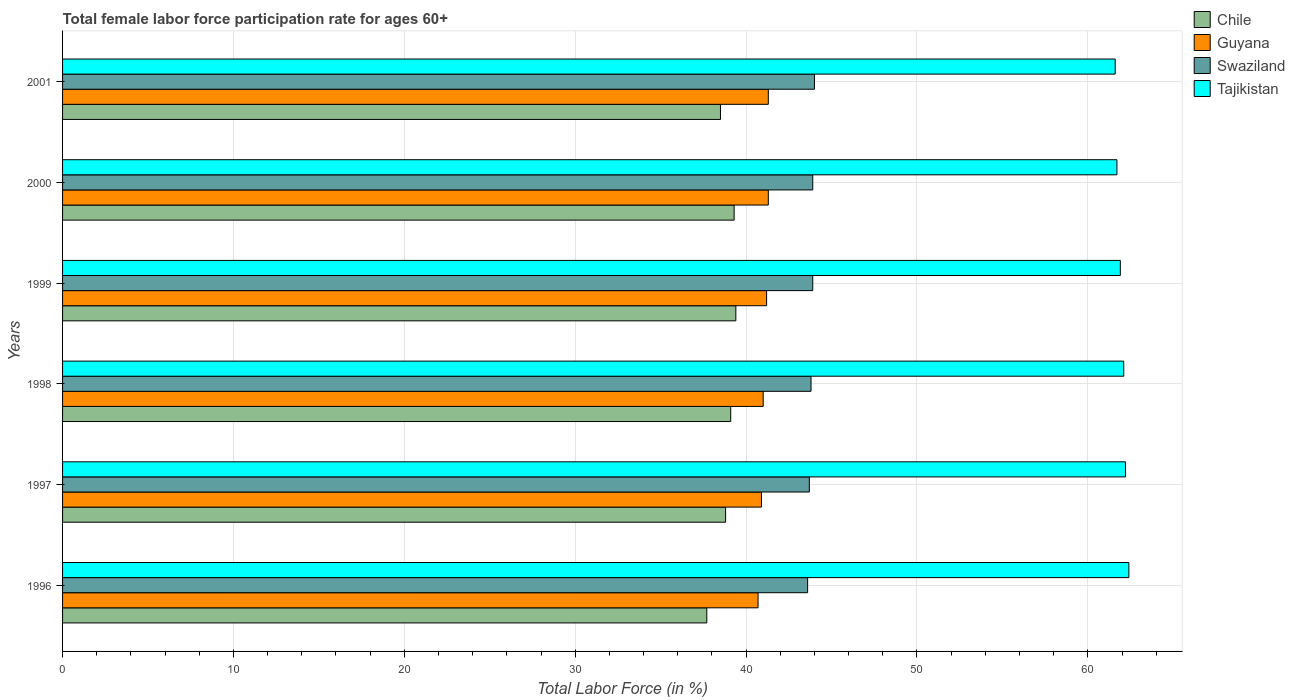How many different coloured bars are there?
Offer a terse response. 4. How many bars are there on the 6th tick from the bottom?
Your answer should be compact. 4. In how many cases, is the number of bars for a given year not equal to the number of legend labels?
Provide a short and direct response. 0. What is the female labor force participation rate in Guyana in 2001?
Offer a very short reply. 41.3. Across all years, what is the maximum female labor force participation rate in Tajikistan?
Your response must be concise. 62.4. Across all years, what is the minimum female labor force participation rate in Chile?
Your answer should be very brief. 37.7. In which year was the female labor force participation rate in Tajikistan maximum?
Your answer should be compact. 1996. What is the total female labor force participation rate in Tajikistan in the graph?
Provide a succinct answer. 371.9. What is the difference between the female labor force participation rate in Tajikistan in 1997 and that in 2000?
Offer a terse response. 0.5. What is the difference between the female labor force participation rate in Chile in 1996 and the female labor force participation rate in Swaziland in 1998?
Offer a very short reply. -6.1. What is the average female labor force participation rate in Tajikistan per year?
Your answer should be very brief. 61.98. In the year 2000, what is the difference between the female labor force participation rate in Chile and female labor force participation rate in Guyana?
Give a very brief answer. -2. What is the ratio of the female labor force participation rate in Tajikistan in 1996 to that in 2001?
Your answer should be compact. 1.01. Is the difference between the female labor force participation rate in Chile in 1996 and 1997 greater than the difference between the female labor force participation rate in Guyana in 1996 and 1997?
Make the answer very short. No. What is the difference between the highest and the second highest female labor force participation rate in Chile?
Provide a succinct answer. 0.1. What is the difference between the highest and the lowest female labor force participation rate in Swaziland?
Your answer should be very brief. 0.4. In how many years, is the female labor force participation rate in Chile greater than the average female labor force participation rate in Chile taken over all years?
Provide a succinct answer. 3. Is the sum of the female labor force participation rate in Guyana in 1996 and 1999 greater than the maximum female labor force participation rate in Chile across all years?
Provide a short and direct response. Yes. What does the 3rd bar from the bottom in 1999 represents?
Offer a terse response. Swaziland. Is it the case that in every year, the sum of the female labor force participation rate in Chile and female labor force participation rate in Swaziland is greater than the female labor force participation rate in Guyana?
Offer a very short reply. Yes. How many years are there in the graph?
Offer a very short reply. 6. Does the graph contain any zero values?
Make the answer very short. No. Where does the legend appear in the graph?
Offer a terse response. Top right. How are the legend labels stacked?
Keep it short and to the point. Vertical. What is the title of the graph?
Offer a terse response. Total female labor force participation rate for ages 60+. Does "Seychelles" appear as one of the legend labels in the graph?
Ensure brevity in your answer.  No. What is the label or title of the X-axis?
Your response must be concise. Total Labor Force (in %). What is the Total Labor Force (in %) in Chile in 1996?
Keep it short and to the point. 37.7. What is the Total Labor Force (in %) in Guyana in 1996?
Make the answer very short. 40.7. What is the Total Labor Force (in %) in Swaziland in 1996?
Offer a very short reply. 43.6. What is the Total Labor Force (in %) in Tajikistan in 1996?
Ensure brevity in your answer.  62.4. What is the Total Labor Force (in %) in Chile in 1997?
Offer a terse response. 38.8. What is the Total Labor Force (in %) in Guyana in 1997?
Provide a succinct answer. 40.9. What is the Total Labor Force (in %) in Swaziland in 1997?
Your answer should be compact. 43.7. What is the Total Labor Force (in %) in Tajikistan in 1997?
Ensure brevity in your answer.  62.2. What is the Total Labor Force (in %) of Chile in 1998?
Provide a short and direct response. 39.1. What is the Total Labor Force (in %) of Guyana in 1998?
Keep it short and to the point. 41. What is the Total Labor Force (in %) of Swaziland in 1998?
Provide a short and direct response. 43.8. What is the Total Labor Force (in %) in Tajikistan in 1998?
Your answer should be very brief. 62.1. What is the Total Labor Force (in %) of Chile in 1999?
Offer a terse response. 39.4. What is the Total Labor Force (in %) of Guyana in 1999?
Offer a very short reply. 41.2. What is the Total Labor Force (in %) in Swaziland in 1999?
Keep it short and to the point. 43.9. What is the Total Labor Force (in %) of Tajikistan in 1999?
Ensure brevity in your answer.  61.9. What is the Total Labor Force (in %) of Chile in 2000?
Provide a short and direct response. 39.3. What is the Total Labor Force (in %) of Guyana in 2000?
Give a very brief answer. 41.3. What is the Total Labor Force (in %) of Swaziland in 2000?
Provide a short and direct response. 43.9. What is the Total Labor Force (in %) in Tajikistan in 2000?
Ensure brevity in your answer.  61.7. What is the Total Labor Force (in %) in Chile in 2001?
Provide a succinct answer. 38.5. What is the Total Labor Force (in %) in Guyana in 2001?
Keep it short and to the point. 41.3. What is the Total Labor Force (in %) in Tajikistan in 2001?
Your answer should be very brief. 61.6. Across all years, what is the maximum Total Labor Force (in %) in Chile?
Your answer should be compact. 39.4. Across all years, what is the maximum Total Labor Force (in %) of Guyana?
Make the answer very short. 41.3. Across all years, what is the maximum Total Labor Force (in %) of Tajikistan?
Provide a short and direct response. 62.4. Across all years, what is the minimum Total Labor Force (in %) of Chile?
Provide a succinct answer. 37.7. Across all years, what is the minimum Total Labor Force (in %) of Guyana?
Ensure brevity in your answer.  40.7. Across all years, what is the minimum Total Labor Force (in %) of Swaziland?
Your answer should be very brief. 43.6. Across all years, what is the minimum Total Labor Force (in %) of Tajikistan?
Your answer should be compact. 61.6. What is the total Total Labor Force (in %) in Chile in the graph?
Your response must be concise. 232.8. What is the total Total Labor Force (in %) of Guyana in the graph?
Your answer should be very brief. 246.4. What is the total Total Labor Force (in %) in Swaziland in the graph?
Ensure brevity in your answer.  262.9. What is the total Total Labor Force (in %) in Tajikistan in the graph?
Ensure brevity in your answer.  371.9. What is the difference between the Total Labor Force (in %) in Chile in 1996 and that in 1997?
Your answer should be very brief. -1.1. What is the difference between the Total Labor Force (in %) of Guyana in 1996 and that in 1997?
Offer a terse response. -0.2. What is the difference between the Total Labor Force (in %) in Swaziland in 1996 and that in 1997?
Make the answer very short. -0.1. What is the difference between the Total Labor Force (in %) in Guyana in 1996 and that in 1999?
Your response must be concise. -0.5. What is the difference between the Total Labor Force (in %) of Swaziland in 1996 and that in 1999?
Keep it short and to the point. -0.3. What is the difference between the Total Labor Force (in %) of Chile in 1996 and that in 2000?
Keep it short and to the point. -1.6. What is the difference between the Total Labor Force (in %) in Swaziland in 1996 and that in 2000?
Your answer should be very brief. -0.3. What is the difference between the Total Labor Force (in %) in Tajikistan in 1996 and that in 2000?
Make the answer very short. 0.7. What is the difference between the Total Labor Force (in %) in Chile in 1996 and that in 2001?
Your answer should be very brief. -0.8. What is the difference between the Total Labor Force (in %) of Guyana in 1996 and that in 2001?
Ensure brevity in your answer.  -0.6. What is the difference between the Total Labor Force (in %) of Chile in 1997 and that in 1998?
Your answer should be very brief. -0.3. What is the difference between the Total Labor Force (in %) of Chile in 1997 and that in 1999?
Give a very brief answer. -0.6. What is the difference between the Total Labor Force (in %) in Swaziland in 1997 and that in 1999?
Your response must be concise. -0.2. What is the difference between the Total Labor Force (in %) in Tajikistan in 1997 and that in 1999?
Your response must be concise. 0.3. What is the difference between the Total Labor Force (in %) in Chile in 1997 and that in 2000?
Your answer should be very brief. -0.5. What is the difference between the Total Labor Force (in %) in Guyana in 1997 and that in 2000?
Your answer should be very brief. -0.4. What is the difference between the Total Labor Force (in %) of Guyana in 1998 and that in 1999?
Provide a succinct answer. -0.2. What is the difference between the Total Labor Force (in %) of Swaziland in 1998 and that in 1999?
Your response must be concise. -0.1. What is the difference between the Total Labor Force (in %) in Guyana in 1998 and that in 2000?
Give a very brief answer. -0.3. What is the difference between the Total Labor Force (in %) of Tajikistan in 1998 and that in 2000?
Make the answer very short. 0.4. What is the difference between the Total Labor Force (in %) of Swaziland in 1998 and that in 2001?
Offer a terse response. -0.2. What is the difference between the Total Labor Force (in %) in Chile in 1999 and that in 2000?
Your response must be concise. 0.1. What is the difference between the Total Labor Force (in %) in Guyana in 1999 and that in 2000?
Provide a succinct answer. -0.1. What is the difference between the Total Labor Force (in %) in Swaziland in 1999 and that in 2000?
Your answer should be compact. 0. What is the difference between the Total Labor Force (in %) of Chile in 1999 and that in 2001?
Provide a short and direct response. 0.9. What is the difference between the Total Labor Force (in %) of Guyana in 1999 and that in 2001?
Your response must be concise. -0.1. What is the difference between the Total Labor Force (in %) in Tajikistan in 1999 and that in 2001?
Your response must be concise. 0.3. What is the difference between the Total Labor Force (in %) in Chile in 2000 and that in 2001?
Offer a very short reply. 0.8. What is the difference between the Total Labor Force (in %) in Swaziland in 2000 and that in 2001?
Ensure brevity in your answer.  -0.1. What is the difference between the Total Labor Force (in %) in Tajikistan in 2000 and that in 2001?
Make the answer very short. 0.1. What is the difference between the Total Labor Force (in %) of Chile in 1996 and the Total Labor Force (in %) of Guyana in 1997?
Provide a short and direct response. -3.2. What is the difference between the Total Labor Force (in %) of Chile in 1996 and the Total Labor Force (in %) of Tajikistan in 1997?
Give a very brief answer. -24.5. What is the difference between the Total Labor Force (in %) of Guyana in 1996 and the Total Labor Force (in %) of Tajikistan in 1997?
Your answer should be compact. -21.5. What is the difference between the Total Labor Force (in %) in Swaziland in 1996 and the Total Labor Force (in %) in Tajikistan in 1997?
Your response must be concise. -18.6. What is the difference between the Total Labor Force (in %) of Chile in 1996 and the Total Labor Force (in %) of Guyana in 1998?
Ensure brevity in your answer.  -3.3. What is the difference between the Total Labor Force (in %) in Chile in 1996 and the Total Labor Force (in %) in Swaziland in 1998?
Your answer should be very brief. -6.1. What is the difference between the Total Labor Force (in %) in Chile in 1996 and the Total Labor Force (in %) in Tajikistan in 1998?
Provide a short and direct response. -24.4. What is the difference between the Total Labor Force (in %) in Guyana in 1996 and the Total Labor Force (in %) in Swaziland in 1998?
Your response must be concise. -3.1. What is the difference between the Total Labor Force (in %) of Guyana in 1996 and the Total Labor Force (in %) of Tajikistan in 1998?
Your answer should be compact. -21.4. What is the difference between the Total Labor Force (in %) in Swaziland in 1996 and the Total Labor Force (in %) in Tajikistan in 1998?
Provide a succinct answer. -18.5. What is the difference between the Total Labor Force (in %) in Chile in 1996 and the Total Labor Force (in %) in Guyana in 1999?
Ensure brevity in your answer.  -3.5. What is the difference between the Total Labor Force (in %) of Chile in 1996 and the Total Labor Force (in %) of Swaziland in 1999?
Your answer should be very brief. -6.2. What is the difference between the Total Labor Force (in %) in Chile in 1996 and the Total Labor Force (in %) in Tajikistan in 1999?
Your answer should be compact. -24.2. What is the difference between the Total Labor Force (in %) of Guyana in 1996 and the Total Labor Force (in %) of Tajikistan in 1999?
Ensure brevity in your answer.  -21.2. What is the difference between the Total Labor Force (in %) of Swaziland in 1996 and the Total Labor Force (in %) of Tajikistan in 1999?
Offer a terse response. -18.3. What is the difference between the Total Labor Force (in %) of Chile in 1996 and the Total Labor Force (in %) of Tajikistan in 2000?
Give a very brief answer. -24. What is the difference between the Total Labor Force (in %) in Guyana in 1996 and the Total Labor Force (in %) in Swaziland in 2000?
Provide a short and direct response. -3.2. What is the difference between the Total Labor Force (in %) in Guyana in 1996 and the Total Labor Force (in %) in Tajikistan in 2000?
Make the answer very short. -21. What is the difference between the Total Labor Force (in %) of Swaziland in 1996 and the Total Labor Force (in %) of Tajikistan in 2000?
Provide a short and direct response. -18.1. What is the difference between the Total Labor Force (in %) in Chile in 1996 and the Total Labor Force (in %) in Swaziland in 2001?
Provide a short and direct response. -6.3. What is the difference between the Total Labor Force (in %) of Chile in 1996 and the Total Labor Force (in %) of Tajikistan in 2001?
Offer a terse response. -23.9. What is the difference between the Total Labor Force (in %) of Guyana in 1996 and the Total Labor Force (in %) of Swaziland in 2001?
Your answer should be very brief. -3.3. What is the difference between the Total Labor Force (in %) in Guyana in 1996 and the Total Labor Force (in %) in Tajikistan in 2001?
Your response must be concise. -20.9. What is the difference between the Total Labor Force (in %) in Swaziland in 1996 and the Total Labor Force (in %) in Tajikistan in 2001?
Your answer should be very brief. -18. What is the difference between the Total Labor Force (in %) of Chile in 1997 and the Total Labor Force (in %) of Tajikistan in 1998?
Make the answer very short. -23.3. What is the difference between the Total Labor Force (in %) in Guyana in 1997 and the Total Labor Force (in %) in Tajikistan in 1998?
Your response must be concise. -21.2. What is the difference between the Total Labor Force (in %) of Swaziland in 1997 and the Total Labor Force (in %) of Tajikistan in 1998?
Offer a terse response. -18.4. What is the difference between the Total Labor Force (in %) of Chile in 1997 and the Total Labor Force (in %) of Tajikistan in 1999?
Your answer should be very brief. -23.1. What is the difference between the Total Labor Force (in %) of Guyana in 1997 and the Total Labor Force (in %) of Swaziland in 1999?
Your answer should be compact. -3. What is the difference between the Total Labor Force (in %) of Guyana in 1997 and the Total Labor Force (in %) of Tajikistan in 1999?
Your response must be concise. -21. What is the difference between the Total Labor Force (in %) of Swaziland in 1997 and the Total Labor Force (in %) of Tajikistan in 1999?
Offer a very short reply. -18.2. What is the difference between the Total Labor Force (in %) of Chile in 1997 and the Total Labor Force (in %) of Tajikistan in 2000?
Make the answer very short. -22.9. What is the difference between the Total Labor Force (in %) in Guyana in 1997 and the Total Labor Force (in %) in Tajikistan in 2000?
Offer a very short reply. -20.8. What is the difference between the Total Labor Force (in %) of Swaziland in 1997 and the Total Labor Force (in %) of Tajikistan in 2000?
Ensure brevity in your answer.  -18. What is the difference between the Total Labor Force (in %) of Chile in 1997 and the Total Labor Force (in %) of Guyana in 2001?
Offer a very short reply. -2.5. What is the difference between the Total Labor Force (in %) in Chile in 1997 and the Total Labor Force (in %) in Swaziland in 2001?
Offer a very short reply. -5.2. What is the difference between the Total Labor Force (in %) of Chile in 1997 and the Total Labor Force (in %) of Tajikistan in 2001?
Provide a succinct answer. -22.8. What is the difference between the Total Labor Force (in %) of Guyana in 1997 and the Total Labor Force (in %) of Swaziland in 2001?
Offer a very short reply. -3.1. What is the difference between the Total Labor Force (in %) in Guyana in 1997 and the Total Labor Force (in %) in Tajikistan in 2001?
Offer a terse response. -20.7. What is the difference between the Total Labor Force (in %) of Swaziland in 1997 and the Total Labor Force (in %) of Tajikistan in 2001?
Your answer should be compact. -17.9. What is the difference between the Total Labor Force (in %) of Chile in 1998 and the Total Labor Force (in %) of Guyana in 1999?
Offer a very short reply. -2.1. What is the difference between the Total Labor Force (in %) in Chile in 1998 and the Total Labor Force (in %) in Swaziland in 1999?
Provide a short and direct response. -4.8. What is the difference between the Total Labor Force (in %) in Chile in 1998 and the Total Labor Force (in %) in Tajikistan in 1999?
Your response must be concise. -22.8. What is the difference between the Total Labor Force (in %) of Guyana in 1998 and the Total Labor Force (in %) of Tajikistan in 1999?
Ensure brevity in your answer.  -20.9. What is the difference between the Total Labor Force (in %) of Swaziland in 1998 and the Total Labor Force (in %) of Tajikistan in 1999?
Provide a succinct answer. -18.1. What is the difference between the Total Labor Force (in %) in Chile in 1998 and the Total Labor Force (in %) in Guyana in 2000?
Your answer should be very brief. -2.2. What is the difference between the Total Labor Force (in %) of Chile in 1998 and the Total Labor Force (in %) of Swaziland in 2000?
Provide a short and direct response. -4.8. What is the difference between the Total Labor Force (in %) of Chile in 1998 and the Total Labor Force (in %) of Tajikistan in 2000?
Give a very brief answer. -22.6. What is the difference between the Total Labor Force (in %) of Guyana in 1998 and the Total Labor Force (in %) of Tajikistan in 2000?
Your answer should be compact. -20.7. What is the difference between the Total Labor Force (in %) of Swaziland in 1998 and the Total Labor Force (in %) of Tajikistan in 2000?
Your response must be concise. -17.9. What is the difference between the Total Labor Force (in %) in Chile in 1998 and the Total Labor Force (in %) in Guyana in 2001?
Keep it short and to the point. -2.2. What is the difference between the Total Labor Force (in %) of Chile in 1998 and the Total Labor Force (in %) of Tajikistan in 2001?
Provide a succinct answer. -22.5. What is the difference between the Total Labor Force (in %) of Guyana in 1998 and the Total Labor Force (in %) of Swaziland in 2001?
Provide a succinct answer. -3. What is the difference between the Total Labor Force (in %) of Guyana in 1998 and the Total Labor Force (in %) of Tajikistan in 2001?
Make the answer very short. -20.6. What is the difference between the Total Labor Force (in %) of Swaziland in 1998 and the Total Labor Force (in %) of Tajikistan in 2001?
Offer a very short reply. -17.8. What is the difference between the Total Labor Force (in %) of Chile in 1999 and the Total Labor Force (in %) of Guyana in 2000?
Provide a short and direct response. -1.9. What is the difference between the Total Labor Force (in %) in Chile in 1999 and the Total Labor Force (in %) in Tajikistan in 2000?
Give a very brief answer. -22.3. What is the difference between the Total Labor Force (in %) in Guyana in 1999 and the Total Labor Force (in %) in Tajikistan in 2000?
Your response must be concise. -20.5. What is the difference between the Total Labor Force (in %) of Swaziland in 1999 and the Total Labor Force (in %) of Tajikistan in 2000?
Your answer should be very brief. -17.8. What is the difference between the Total Labor Force (in %) in Chile in 1999 and the Total Labor Force (in %) in Guyana in 2001?
Offer a terse response. -1.9. What is the difference between the Total Labor Force (in %) in Chile in 1999 and the Total Labor Force (in %) in Swaziland in 2001?
Offer a terse response. -4.6. What is the difference between the Total Labor Force (in %) in Chile in 1999 and the Total Labor Force (in %) in Tajikistan in 2001?
Provide a short and direct response. -22.2. What is the difference between the Total Labor Force (in %) of Guyana in 1999 and the Total Labor Force (in %) of Tajikistan in 2001?
Your answer should be compact. -20.4. What is the difference between the Total Labor Force (in %) in Swaziland in 1999 and the Total Labor Force (in %) in Tajikistan in 2001?
Give a very brief answer. -17.7. What is the difference between the Total Labor Force (in %) in Chile in 2000 and the Total Labor Force (in %) in Tajikistan in 2001?
Offer a terse response. -22.3. What is the difference between the Total Labor Force (in %) in Guyana in 2000 and the Total Labor Force (in %) in Swaziland in 2001?
Ensure brevity in your answer.  -2.7. What is the difference between the Total Labor Force (in %) in Guyana in 2000 and the Total Labor Force (in %) in Tajikistan in 2001?
Ensure brevity in your answer.  -20.3. What is the difference between the Total Labor Force (in %) in Swaziland in 2000 and the Total Labor Force (in %) in Tajikistan in 2001?
Give a very brief answer. -17.7. What is the average Total Labor Force (in %) of Chile per year?
Provide a short and direct response. 38.8. What is the average Total Labor Force (in %) in Guyana per year?
Make the answer very short. 41.07. What is the average Total Labor Force (in %) in Swaziland per year?
Give a very brief answer. 43.82. What is the average Total Labor Force (in %) of Tajikistan per year?
Ensure brevity in your answer.  61.98. In the year 1996, what is the difference between the Total Labor Force (in %) of Chile and Total Labor Force (in %) of Guyana?
Provide a short and direct response. -3. In the year 1996, what is the difference between the Total Labor Force (in %) of Chile and Total Labor Force (in %) of Swaziland?
Provide a short and direct response. -5.9. In the year 1996, what is the difference between the Total Labor Force (in %) in Chile and Total Labor Force (in %) in Tajikistan?
Provide a short and direct response. -24.7. In the year 1996, what is the difference between the Total Labor Force (in %) in Guyana and Total Labor Force (in %) in Swaziland?
Offer a very short reply. -2.9. In the year 1996, what is the difference between the Total Labor Force (in %) of Guyana and Total Labor Force (in %) of Tajikistan?
Your answer should be compact. -21.7. In the year 1996, what is the difference between the Total Labor Force (in %) in Swaziland and Total Labor Force (in %) in Tajikistan?
Your answer should be compact. -18.8. In the year 1997, what is the difference between the Total Labor Force (in %) in Chile and Total Labor Force (in %) in Tajikistan?
Offer a very short reply. -23.4. In the year 1997, what is the difference between the Total Labor Force (in %) of Guyana and Total Labor Force (in %) of Swaziland?
Provide a succinct answer. -2.8. In the year 1997, what is the difference between the Total Labor Force (in %) in Guyana and Total Labor Force (in %) in Tajikistan?
Provide a succinct answer. -21.3. In the year 1997, what is the difference between the Total Labor Force (in %) in Swaziland and Total Labor Force (in %) in Tajikistan?
Give a very brief answer. -18.5. In the year 1998, what is the difference between the Total Labor Force (in %) in Chile and Total Labor Force (in %) in Guyana?
Provide a succinct answer. -1.9. In the year 1998, what is the difference between the Total Labor Force (in %) of Chile and Total Labor Force (in %) of Swaziland?
Keep it short and to the point. -4.7. In the year 1998, what is the difference between the Total Labor Force (in %) in Chile and Total Labor Force (in %) in Tajikistan?
Provide a short and direct response. -23. In the year 1998, what is the difference between the Total Labor Force (in %) of Guyana and Total Labor Force (in %) of Swaziland?
Offer a terse response. -2.8. In the year 1998, what is the difference between the Total Labor Force (in %) of Guyana and Total Labor Force (in %) of Tajikistan?
Your answer should be very brief. -21.1. In the year 1998, what is the difference between the Total Labor Force (in %) in Swaziland and Total Labor Force (in %) in Tajikistan?
Keep it short and to the point. -18.3. In the year 1999, what is the difference between the Total Labor Force (in %) in Chile and Total Labor Force (in %) in Guyana?
Offer a terse response. -1.8. In the year 1999, what is the difference between the Total Labor Force (in %) of Chile and Total Labor Force (in %) of Tajikistan?
Provide a short and direct response. -22.5. In the year 1999, what is the difference between the Total Labor Force (in %) of Guyana and Total Labor Force (in %) of Swaziland?
Give a very brief answer. -2.7. In the year 1999, what is the difference between the Total Labor Force (in %) in Guyana and Total Labor Force (in %) in Tajikistan?
Provide a short and direct response. -20.7. In the year 1999, what is the difference between the Total Labor Force (in %) in Swaziland and Total Labor Force (in %) in Tajikistan?
Your response must be concise. -18. In the year 2000, what is the difference between the Total Labor Force (in %) in Chile and Total Labor Force (in %) in Guyana?
Offer a terse response. -2. In the year 2000, what is the difference between the Total Labor Force (in %) of Chile and Total Labor Force (in %) of Tajikistan?
Your answer should be very brief. -22.4. In the year 2000, what is the difference between the Total Labor Force (in %) of Guyana and Total Labor Force (in %) of Swaziland?
Give a very brief answer. -2.6. In the year 2000, what is the difference between the Total Labor Force (in %) of Guyana and Total Labor Force (in %) of Tajikistan?
Provide a short and direct response. -20.4. In the year 2000, what is the difference between the Total Labor Force (in %) of Swaziland and Total Labor Force (in %) of Tajikistan?
Ensure brevity in your answer.  -17.8. In the year 2001, what is the difference between the Total Labor Force (in %) of Chile and Total Labor Force (in %) of Swaziland?
Provide a short and direct response. -5.5. In the year 2001, what is the difference between the Total Labor Force (in %) in Chile and Total Labor Force (in %) in Tajikistan?
Keep it short and to the point. -23.1. In the year 2001, what is the difference between the Total Labor Force (in %) of Guyana and Total Labor Force (in %) of Swaziland?
Keep it short and to the point. -2.7. In the year 2001, what is the difference between the Total Labor Force (in %) in Guyana and Total Labor Force (in %) in Tajikistan?
Provide a short and direct response. -20.3. In the year 2001, what is the difference between the Total Labor Force (in %) in Swaziland and Total Labor Force (in %) in Tajikistan?
Your answer should be compact. -17.6. What is the ratio of the Total Labor Force (in %) of Chile in 1996 to that in 1997?
Ensure brevity in your answer.  0.97. What is the ratio of the Total Labor Force (in %) of Guyana in 1996 to that in 1997?
Keep it short and to the point. 1. What is the ratio of the Total Labor Force (in %) in Swaziland in 1996 to that in 1997?
Offer a terse response. 1. What is the ratio of the Total Labor Force (in %) of Chile in 1996 to that in 1998?
Your answer should be compact. 0.96. What is the ratio of the Total Labor Force (in %) in Tajikistan in 1996 to that in 1998?
Provide a short and direct response. 1. What is the ratio of the Total Labor Force (in %) of Chile in 1996 to that in 1999?
Ensure brevity in your answer.  0.96. What is the ratio of the Total Labor Force (in %) of Guyana in 1996 to that in 1999?
Offer a terse response. 0.99. What is the ratio of the Total Labor Force (in %) in Swaziland in 1996 to that in 1999?
Ensure brevity in your answer.  0.99. What is the ratio of the Total Labor Force (in %) in Tajikistan in 1996 to that in 1999?
Ensure brevity in your answer.  1.01. What is the ratio of the Total Labor Force (in %) in Chile in 1996 to that in 2000?
Your answer should be very brief. 0.96. What is the ratio of the Total Labor Force (in %) of Guyana in 1996 to that in 2000?
Offer a very short reply. 0.99. What is the ratio of the Total Labor Force (in %) of Tajikistan in 1996 to that in 2000?
Provide a short and direct response. 1.01. What is the ratio of the Total Labor Force (in %) of Chile in 1996 to that in 2001?
Provide a short and direct response. 0.98. What is the ratio of the Total Labor Force (in %) in Guyana in 1996 to that in 2001?
Your answer should be very brief. 0.99. What is the ratio of the Total Labor Force (in %) in Swaziland in 1996 to that in 2001?
Make the answer very short. 0.99. What is the ratio of the Total Labor Force (in %) of Chile in 1997 to that in 1999?
Give a very brief answer. 0.98. What is the ratio of the Total Labor Force (in %) of Swaziland in 1997 to that in 1999?
Ensure brevity in your answer.  1. What is the ratio of the Total Labor Force (in %) of Chile in 1997 to that in 2000?
Offer a very short reply. 0.99. What is the ratio of the Total Labor Force (in %) in Guyana in 1997 to that in 2000?
Your answer should be compact. 0.99. What is the ratio of the Total Labor Force (in %) of Swaziland in 1997 to that in 2000?
Your answer should be very brief. 1. What is the ratio of the Total Labor Force (in %) in Guyana in 1997 to that in 2001?
Offer a terse response. 0.99. What is the ratio of the Total Labor Force (in %) of Swaziland in 1997 to that in 2001?
Ensure brevity in your answer.  0.99. What is the ratio of the Total Labor Force (in %) of Tajikistan in 1997 to that in 2001?
Provide a short and direct response. 1.01. What is the ratio of the Total Labor Force (in %) of Tajikistan in 1998 to that in 1999?
Your answer should be very brief. 1. What is the ratio of the Total Labor Force (in %) of Chile in 1998 to that in 2000?
Your answer should be very brief. 0.99. What is the ratio of the Total Labor Force (in %) in Swaziland in 1998 to that in 2000?
Your response must be concise. 1. What is the ratio of the Total Labor Force (in %) of Chile in 1998 to that in 2001?
Offer a very short reply. 1.02. What is the ratio of the Total Labor Force (in %) of Guyana in 1998 to that in 2001?
Your response must be concise. 0.99. What is the ratio of the Total Labor Force (in %) of Tajikistan in 1998 to that in 2001?
Offer a terse response. 1.01. What is the ratio of the Total Labor Force (in %) of Tajikistan in 1999 to that in 2000?
Make the answer very short. 1. What is the ratio of the Total Labor Force (in %) in Chile in 1999 to that in 2001?
Make the answer very short. 1.02. What is the ratio of the Total Labor Force (in %) in Guyana in 1999 to that in 2001?
Make the answer very short. 1. What is the ratio of the Total Labor Force (in %) of Chile in 2000 to that in 2001?
Make the answer very short. 1.02. What is the difference between the highest and the second highest Total Labor Force (in %) in Chile?
Your answer should be very brief. 0.1. What is the difference between the highest and the second highest Total Labor Force (in %) of Tajikistan?
Provide a succinct answer. 0.2. What is the difference between the highest and the lowest Total Labor Force (in %) of Chile?
Offer a terse response. 1.7. What is the difference between the highest and the lowest Total Labor Force (in %) of Guyana?
Your answer should be very brief. 0.6. What is the difference between the highest and the lowest Total Labor Force (in %) in Swaziland?
Your response must be concise. 0.4. What is the difference between the highest and the lowest Total Labor Force (in %) of Tajikistan?
Give a very brief answer. 0.8. 